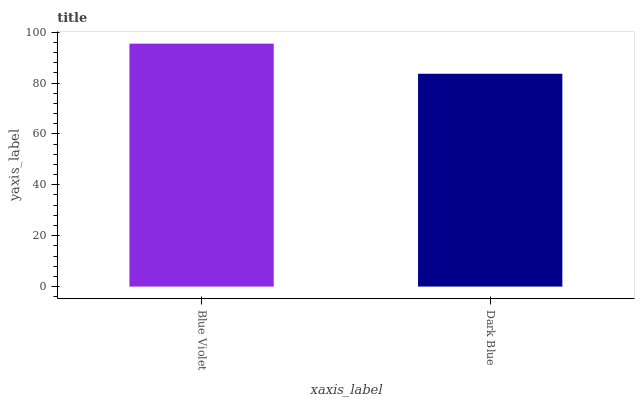Is Dark Blue the maximum?
Answer yes or no. No. Is Blue Violet greater than Dark Blue?
Answer yes or no. Yes. Is Dark Blue less than Blue Violet?
Answer yes or no. Yes. Is Dark Blue greater than Blue Violet?
Answer yes or no. No. Is Blue Violet less than Dark Blue?
Answer yes or no. No. Is Blue Violet the high median?
Answer yes or no. Yes. Is Dark Blue the low median?
Answer yes or no. Yes. Is Dark Blue the high median?
Answer yes or no. No. Is Blue Violet the low median?
Answer yes or no. No. 